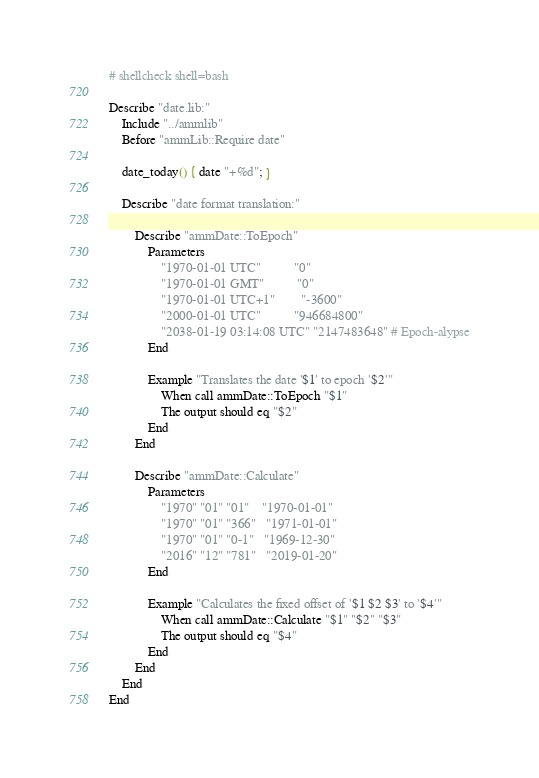<code> <loc_0><loc_0><loc_500><loc_500><_Bash_># shellcheck shell=bash

Describe "date.lib:"
	Include "../ammlib"
	Before "ammLib::Require date"

	date_today() { date "+%d"; }

	Describe "date format translation:"

		Describe "ammDate::ToEpoch"
			Parameters
				"1970-01-01 UTC"          "0"
				"1970-01-01 GMT"          "0"
				"1970-01-01 UTC+1"        "-3600"
				"2000-01-01 UTC"          "946684800"
				"2038-01-19 03:14:08 UTC" "2147483648" # Epoch-alypse
			End

			Example "Translates the date '$1' to epoch '$2'"
				When call ammDate::ToEpoch "$1"
				The output should eq "$2"
			End
		End

		Describe "ammDate::Calculate"
			Parameters
				"1970" "01" "01"    "1970-01-01"
				"1970" "01" "366"   "1971-01-01"
				"1970" "01" "0-1"   "1969-12-30"
				"2016" "12" "781"   "2019-01-20"
			End

			Example "Calculates the fixed offset of '$1 $2 $3' to '$4'"
				When call ammDate::Calculate "$1" "$2" "$3"
				The output should eq "$4"
			End
		End
	End
End
</code> 